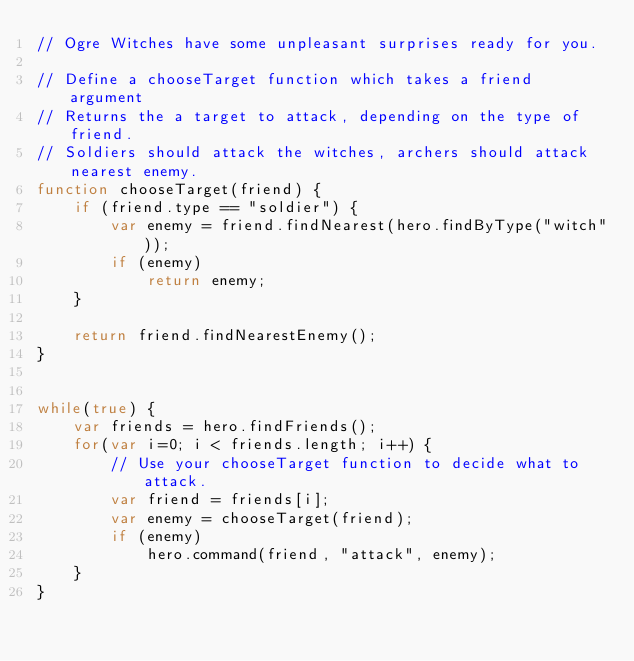Convert code to text. <code><loc_0><loc_0><loc_500><loc_500><_JavaScript_>// Ogre Witches have some unpleasant surprises ready for you.

// Define a chooseTarget function which takes a friend argument
// Returns the a target to attack, depending on the type of friend.
// Soldiers should attack the witches, archers should attack nearest enemy.
function chooseTarget(friend) {
    if (friend.type == "soldier") {
        var enemy = friend.findNearest(hero.findByType("witch"));
        if (enemy)
            return enemy;
    }

    return friend.findNearestEnemy();
}


while(true) {
    var friends = hero.findFriends();
    for(var i=0; i < friends.length; i++) {
        // Use your chooseTarget function to decide what to attack.
        var friend = friends[i];
        var enemy = chooseTarget(friend);
        if (enemy)
            hero.command(friend, "attack", enemy);
    }
}
</code> 